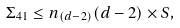Convert formula to latex. <formula><loc_0><loc_0><loc_500><loc_500>\Sigma _ { 4 1 } \leq n _ { ( d - 2 ) } ( d - 2 ) \times S ,</formula> 